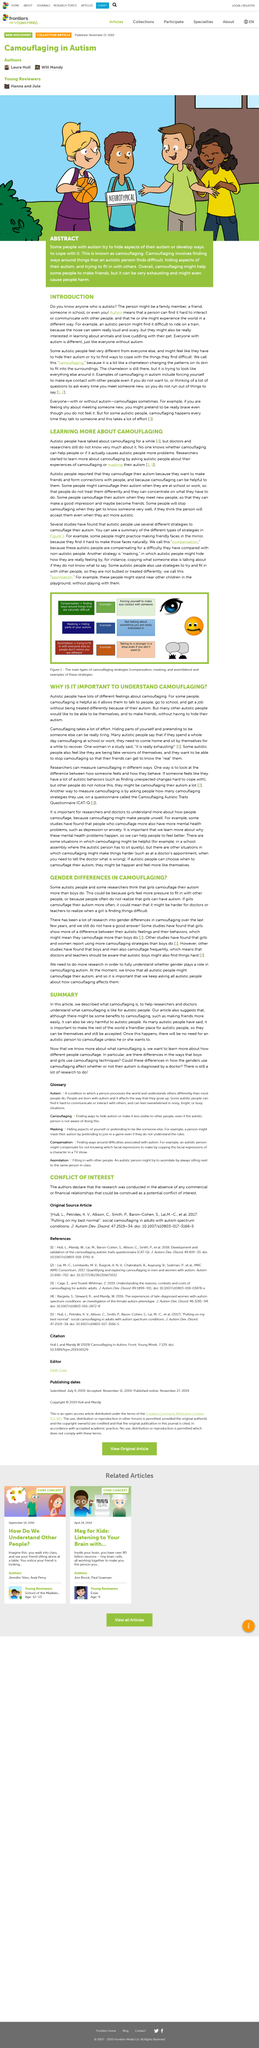Give some essential details in this illustration. It is called masking when autistic people hide their feelings. What is the article about? It is about autism. Autistic individuals have a wide range of feelings regarding camouflaging, including both positive and negative sentiments. Practicing looking at friendly faces in the mirror is called compensation. Autistic individuals recover from camouflaging by returning home and engaging in self-reflection and quiet time alone. 